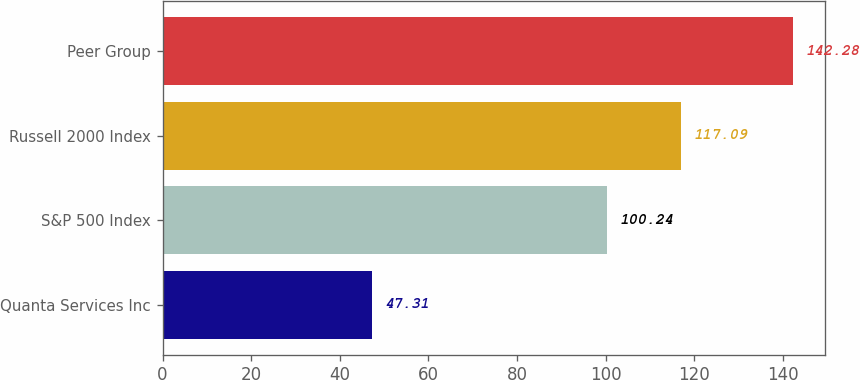Convert chart to OTSL. <chart><loc_0><loc_0><loc_500><loc_500><bar_chart><fcel>Quanta Services Inc<fcel>S&P 500 Index<fcel>Russell 2000 Index<fcel>Peer Group<nl><fcel>47.31<fcel>100.24<fcel>117.09<fcel>142.28<nl></chart> 